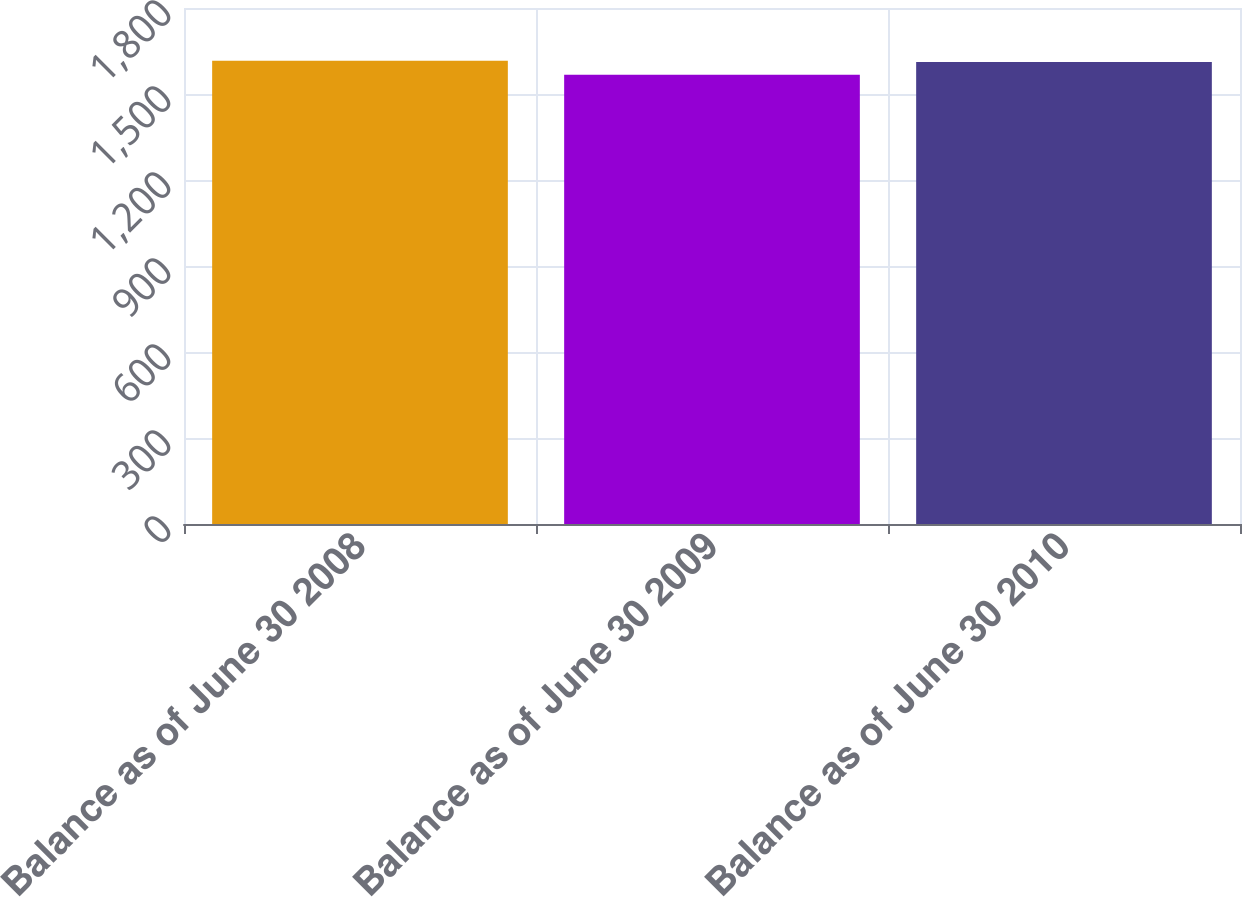Convert chart to OTSL. <chart><loc_0><loc_0><loc_500><loc_500><bar_chart><fcel>Balance as of June 30 2008<fcel>Balance as of June 30 2009<fcel>Balance as of June 30 2010<nl><fcel>1616.17<fcel>1567<fcel>1611.3<nl></chart> 